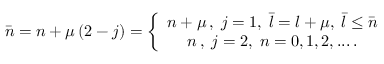Convert formula to latex. <formula><loc_0><loc_0><loc_500><loc_500>\bar { n } = n + \mu \left ( 2 - j \right ) = \left \{ \begin{array} { c } { { n + \mu \, , \, j = 1 , \, \bar { l } = l + \mu , \, \bar { l } \leq \bar { n } } } \\ { n \, , \, j = 2 , \, n = 0 , 1 , 2 , \dots \, . } \end{array}</formula> 